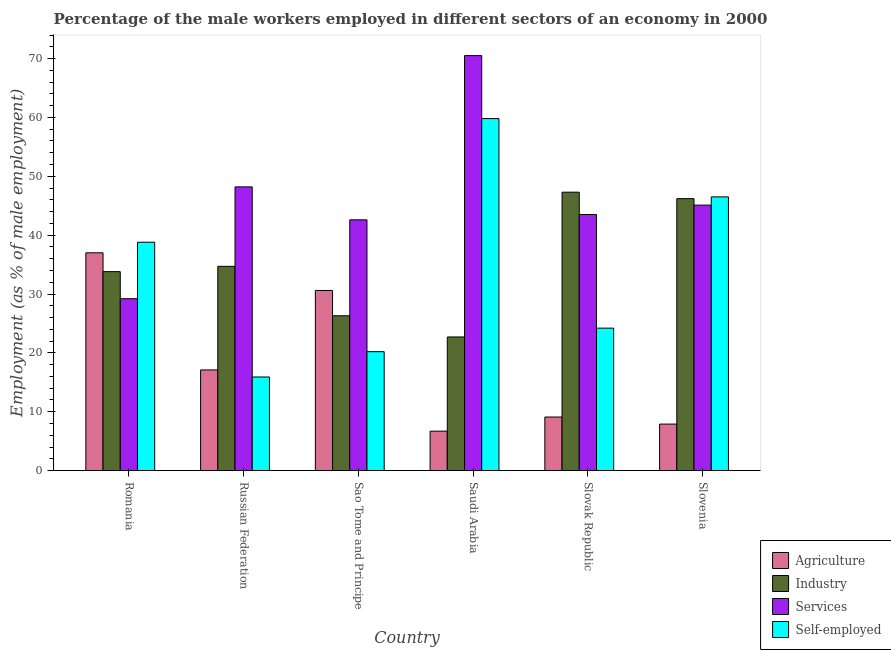How many bars are there on the 4th tick from the left?
Ensure brevity in your answer.  4. How many bars are there on the 5th tick from the right?
Your answer should be very brief. 4. What is the label of the 1st group of bars from the left?
Make the answer very short. Romania. In how many cases, is the number of bars for a given country not equal to the number of legend labels?
Offer a very short reply. 0. What is the percentage of self employed male workers in Saudi Arabia?
Give a very brief answer. 59.8. Across all countries, what is the maximum percentage of self employed male workers?
Make the answer very short. 59.8. Across all countries, what is the minimum percentage of male workers in agriculture?
Keep it short and to the point. 6.7. In which country was the percentage of male workers in services maximum?
Ensure brevity in your answer.  Saudi Arabia. In which country was the percentage of male workers in industry minimum?
Your response must be concise. Saudi Arabia. What is the total percentage of male workers in agriculture in the graph?
Keep it short and to the point. 108.4. What is the difference between the percentage of male workers in agriculture in Romania and that in Slovenia?
Offer a very short reply. 29.1. What is the difference between the percentage of male workers in industry in Romania and the percentage of male workers in agriculture in Russian Federation?
Ensure brevity in your answer.  16.7. What is the average percentage of male workers in services per country?
Make the answer very short. 46.52. What is the difference between the percentage of male workers in services and percentage of male workers in industry in Saudi Arabia?
Ensure brevity in your answer.  47.8. What is the ratio of the percentage of male workers in industry in Sao Tome and Principe to that in Slovenia?
Keep it short and to the point. 0.57. What is the difference between the highest and the second highest percentage of male workers in industry?
Keep it short and to the point. 1.1. What is the difference between the highest and the lowest percentage of male workers in agriculture?
Offer a very short reply. 30.3. What does the 1st bar from the left in Romania represents?
Give a very brief answer. Agriculture. What does the 3rd bar from the right in Slovak Republic represents?
Offer a very short reply. Industry. Is it the case that in every country, the sum of the percentage of male workers in agriculture and percentage of male workers in industry is greater than the percentage of male workers in services?
Offer a terse response. No. Are all the bars in the graph horizontal?
Provide a short and direct response. No. Where does the legend appear in the graph?
Your answer should be compact. Bottom right. What is the title of the graph?
Your answer should be compact. Percentage of the male workers employed in different sectors of an economy in 2000. What is the label or title of the Y-axis?
Offer a very short reply. Employment (as % of male employment). What is the Employment (as % of male employment) in Industry in Romania?
Your response must be concise. 33.8. What is the Employment (as % of male employment) of Services in Romania?
Offer a very short reply. 29.2. What is the Employment (as % of male employment) in Self-employed in Romania?
Provide a succinct answer. 38.8. What is the Employment (as % of male employment) in Agriculture in Russian Federation?
Your response must be concise. 17.1. What is the Employment (as % of male employment) of Industry in Russian Federation?
Provide a succinct answer. 34.7. What is the Employment (as % of male employment) in Services in Russian Federation?
Provide a succinct answer. 48.2. What is the Employment (as % of male employment) of Self-employed in Russian Federation?
Your answer should be very brief. 15.9. What is the Employment (as % of male employment) of Agriculture in Sao Tome and Principe?
Give a very brief answer. 30.6. What is the Employment (as % of male employment) in Industry in Sao Tome and Principe?
Offer a terse response. 26.3. What is the Employment (as % of male employment) in Services in Sao Tome and Principe?
Give a very brief answer. 42.6. What is the Employment (as % of male employment) of Self-employed in Sao Tome and Principe?
Give a very brief answer. 20.2. What is the Employment (as % of male employment) in Agriculture in Saudi Arabia?
Give a very brief answer. 6.7. What is the Employment (as % of male employment) in Industry in Saudi Arabia?
Your answer should be very brief. 22.7. What is the Employment (as % of male employment) of Services in Saudi Arabia?
Offer a very short reply. 70.5. What is the Employment (as % of male employment) in Self-employed in Saudi Arabia?
Provide a short and direct response. 59.8. What is the Employment (as % of male employment) in Agriculture in Slovak Republic?
Provide a succinct answer. 9.1. What is the Employment (as % of male employment) of Industry in Slovak Republic?
Keep it short and to the point. 47.3. What is the Employment (as % of male employment) in Services in Slovak Republic?
Make the answer very short. 43.5. What is the Employment (as % of male employment) of Self-employed in Slovak Republic?
Ensure brevity in your answer.  24.2. What is the Employment (as % of male employment) of Agriculture in Slovenia?
Offer a terse response. 7.9. What is the Employment (as % of male employment) in Industry in Slovenia?
Your answer should be compact. 46.2. What is the Employment (as % of male employment) of Services in Slovenia?
Your answer should be compact. 45.1. What is the Employment (as % of male employment) in Self-employed in Slovenia?
Your response must be concise. 46.5. Across all countries, what is the maximum Employment (as % of male employment) in Agriculture?
Keep it short and to the point. 37. Across all countries, what is the maximum Employment (as % of male employment) of Industry?
Provide a succinct answer. 47.3. Across all countries, what is the maximum Employment (as % of male employment) of Services?
Your response must be concise. 70.5. Across all countries, what is the maximum Employment (as % of male employment) of Self-employed?
Give a very brief answer. 59.8. Across all countries, what is the minimum Employment (as % of male employment) in Agriculture?
Offer a terse response. 6.7. Across all countries, what is the minimum Employment (as % of male employment) in Industry?
Offer a terse response. 22.7. Across all countries, what is the minimum Employment (as % of male employment) in Services?
Provide a short and direct response. 29.2. Across all countries, what is the minimum Employment (as % of male employment) of Self-employed?
Your response must be concise. 15.9. What is the total Employment (as % of male employment) of Agriculture in the graph?
Provide a succinct answer. 108.4. What is the total Employment (as % of male employment) of Industry in the graph?
Ensure brevity in your answer.  211. What is the total Employment (as % of male employment) of Services in the graph?
Make the answer very short. 279.1. What is the total Employment (as % of male employment) of Self-employed in the graph?
Your answer should be compact. 205.4. What is the difference between the Employment (as % of male employment) of Agriculture in Romania and that in Russian Federation?
Offer a very short reply. 19.9. What is the difference between the Employment (as % of male employment) in Industry in Romania and that in Russian Federation?
Your answer should be very brief. -0.9. What is the difference between the Employment (as % of male employment) of Self-employed in Romania and that in Russian Federation?
Your response must be concise. 22.9. What is the difference between the Employment (as % of male employment) of Industry in Romania and that in Sao Tome and Principe?
Offer a very short reply. 7.5. What is the difference between the Employment (as % of male employment) of Self-employed in Romania and that in Sao Tome and Principe?
Your answer should be very brief. 18.6. What is the difference between the Employment (as % of male employment) in Agriculture in Romania and that in Saudi Arabia?
Offer a terse response. 30.3. What is the difference between the Employment (as % of male employment) of Industry in Romania and that in Saudi Arabia?
Your answer should be compact. 11.1. What is the difference between the Employment (as % of male employment) in Services in Romania and that in Saudi Arabia?
Provide a succinct answer. -41.3. What is the difference between the Employment (as % of male employment) in Self-employed in Romania and that in Saudi Arabia?
Keep it short and to the point. -21. What is the difference between the Employment (as % of male employment) of Agriculture in Romania and that in Slovak Republic?
Give a very brief answer. 27.9. What is the difference between the Employment (as % of male employment) in Services in Romania and that in Slovak Republic?
Give a very brief answer. -14.3. What is the difference between the Employment (as % of male employment) of Agriculture in Romania and that in Slovenia?
Provide a short and direct response. 29.1. What is the difference between the Employment (as % of male employment) of Industry in Romania and that in Slovenia?
Offer a terse response. -12.4. What is the difference between the Employment (as % of male employment) in Services in Romania and that in Slovenia?
Offer a terse response. -15.9. What is the difference between the Employment (as % of male employment) in Self-employed in Romania and that in Slovenia?
Offer a very short reply. -7.7. What is the difference between the Employment (as % of male employment) of Industry in Russian Federation and that in Sao Tome and Principe?
Your response must be concise. 8.4. What is the difference between the Employment (as % of male employment) of Services in Russian Federation and that in Sao Tome and Principe?
Your answer should be very brief. 5.6. What is the difference between the Employment (as % of male employment) in Self-employed in Russian Federation and that in Sao Tome and Principe?
Make the answer very short. -4.3. What is the difference between the Employment (as % of male employment) in Services in Russian Federation and that in Saudi Arabia?
Provide a succinct answer. -22.3. What is the difference between the Employment (as % of male employment) in Self-employed in Russian Federation and that in Saudi Arabia?
Your response must be concise. -43.9. What is the difference between the Employment (as % of male employment) of Agriculture in Russian Federation and that in Slovak Republic?
Your response must be concise. 8. What is the difference between the Employment (as % of male employment) of Services in Russian Federation and that in Slovak Republic?
Make the answer very short. 4.7. What is the difference between the Employment (as % of male employment) of Self-employed in Russian Federation and that in Slovak Republic?
Offer a terse response. -8.3. What is the difference between the Employment (as % of male employment) in Services in Russian Federation and that in Slovenia?
Provide a short and direct response. 3.1. What is the difference between the Employment (as % of male employment) of Self-employed in Russian Federation and that in Slovenia?
Ensure brevity in your answer.  -30.6. What is the difference between the Employment (as % of male employment) of Agriculture in Sao Tome and Principe and that in Saudi Arabia?
Make the answer very short. 23.9. What is the difference between the Employment (as % of male employment) of Services in Sao Tome and Principe and that in Saudi Arabia?
Provide a succinct answer. -27.9. What is the difference between the Employment (as % of male employment) of Self-employed in Sao Tome and Principe and that in Saudi Arabia?
Make the answer very short. -39.6. What is the difference between the Employment (as % of male employment) of Industry in Sao Tome and Principe and that in Slovak Republic?
Your answer should be compact. -21. What is the difference between the Employment (as % of male employment) in Agriculture in Sao Tome and Principe and that in Slovenia?
Provide a short and direct response. 22.7. What is the difference between the Employment (as % of male employment) in Industry in Sao Tome and Principe and that in Slovenia?
Ensure brevity in your answer.  -19.9. What is the difference between the Employment (as % of male employment) in Self-employed in Sao Tome and Principe and that in Slovenia?
Offer a very short reply. -26.3. What is the difference between the Employment (as % of male employment) in Agriculture in Saudi Arabia and that in Slovak Republic?
Ensure brevity in your answer.  -2.4. What is the difference between the Employment (as % of male employment) of Industry in Saudi Arabia and that in Slovak Republic?
Give a very brief answer. -24.6. What is the difference between the Employment (as % of male employment) in Self-employed in Saudi Arabia and that in Slovak Republic?
Provide a succinct answer. 35.6. What is the difference between the Employment (as % of male employment) of Agriculture in Saudi Arabia and that in Slovenia?
Offer a very short reply. -1.2. What is the difference between the Employment (as % of male employment) of Industry in Saudi Arabia and that in Slovenia?
Make the answer very short. -23.5. What is the difference between the Employment (as % of male employment) in Services in Saudi Arabia and that in Slovenia?
Offer a terse response. 25.4. What is the difference between the Employment (as % of male employment) in Self-employed in Saudi Arabia and that in Slovenia?
Your answer should be compact. 13.3. What is the difference between the Employment (as % of male employment) of Agriculture in Slovak Republic and that in Slovenia?
Give a very brief answer. 1.2. What is the difference between the Employment (as % of male employment) of Industry in Slovak Republic and that in Slovenia?
Make the answer very short. 1.1. What is the difference between the Employment (as % of male employment) of Self-employed in Slovak Republic and that in Slovenia?
Your answer should be very brief. -22.3. What is the difference between the Employment (as % of male employment) of Agriculture in Romania and the Employment (as % of male employment) of Self-employed in Russian Federation?
Keep it short and to the point. 21.1. What is the difference between the Employment (as % of male employment) in Industry in Romania and the Employment (as % of male employment) in Services in Russian Federation?
Offer a terse response. -14.4. What is the difference between the Employment (as % of male employment) of Industry in Romania and the Employment (as % of male employment) of Self-employed in Russian Federation?
Provide a short and direct response. 17.9. What is the difference between the Employment (as % of male employment) of Agriculture in Romania and the Employment (as % of male employment) of Industry in Sao Tome and Principe?
Provide a short and direct response. 10.7. What is the difference between the Employment (as % of male employment) of Industry in Romania and the Employment (as % of male employment) of Self-employed in Sao Tome and Principe?
Keep it short and to the point. 13.6. What is the difference between the Employment (as % of male employment) in Services in Romania and the Employment (as % of male employment) in Self-employed in Sao Tome and Principe?
Offer a terse response. 9. What is the difference between the Employment (as % of male employment) of Agriculture in Romania and the Employment (as % of male employment) of Industry in Saudi Arabia?
Ensure brevity in your answer.  14.3. What is the difference between the Employment (as % of male employment) of Agriculture in Romania and the Employment (as % of male employment) of Services in Saudi Arabia?
Give a very brief answer. -33.5. What is the difference between the Employment (as % of male employment) in Agriculture in Romania and the Employment (as % of male employment) in Self-employed in Saudi Arabia?
Your answer should be very brief. -22.8. What is the difference between the Employment (as % of male employment) in Industry in Romania and the Employment (as % of male employment) in Services in Saudi Arabia?
Make the answer very short. -36.7. What is the difference between the Employment (as % of male employment) of Services in Romania and the Employment (as % of male employment) of Self-employed in Saudi Arabia?
Make the answer very short. -30.6. What is the difference between the Employment (as % of male employment) of Agriculture in Romania and the Employment (as % of male employment) of Industry in Slovak Republic?
Keep it short and to the point. -10.3. What is the difference between the Employment (as % of male employment) in Industry in Romania and the Employment (as % of male employment) in Services in Slovak Republic?
Your response must be concise. -9.7. What is the difference between the Employment (as % of male employment) of Industry in Romania and the Employment (as % of male employment) of Self-employed in Slovak Republic?
Keep it short and to the point. 9.6. What is the difference between the Employment (as % of male employment) in Agriculture in Romania and the Employment (as % of male employment) in Industry in Slovenia?
Keep it short and to the point. -9.2. What is the difference between the Employment (as % of male employment) in Industry in Romania and the Employment (as % of male employment) in Services in Slovenia?
Your response must be concise. -11.3. What is the difference between the Employment (as % of male employment) of Services in Romania and the Employment (as % of male employment) of Self-employed in Slovenia?
Give a very brief answer. -17.3. What is the difference between the Employment (as % of male employment) of Agriculture in Russian Federation and the Employment (as % of male employment) of Industry in Sao Tome and Principe?
Make the answer very short. -9.2. What is the difference between the Employment (as % of male employment) of Agriculture in Russian Federation and the Employment (as % of male employment) of Services in Sao Tome and Principe?
Offer a very short reply. -25.5. What is the difference between the Employment (as % of male employment) of Agriculture in Russian Federation and the Employment (as % of male employment) of Self-employed in Sao Tome and Principe?
Make the answer very short. -3.1. What is the difference between the Employment (as % of male employment) in Industry in Russian Federation and the Employment (as % of male employment) in Services in Sao Tome and Principe?
Make the answer very short. -7.9. What is the difference between the Employment (as % of male employment) of Industry in Russian Federation and the Employment (as % of male employment) of Self-employed in Sao Tome and Principe?
Give a very brief answer. 14.5. What is the difference between the Employment (as % of male employment) in Agriculture in Russian Federation and the Employment (as % of male employment) in Services in Saudi Arabia?
Your answer should be very brief. -53.4. What is the difference between the Employment (as % of male employment) in Agriculture in Russian Federation and the Employment (as % of male employment) in Self-employed in Saudi Arabia?
Make the answer very short. -42.7. What is the difference between the Employment (as % of male employment) of Industry in Russian Federation and the Employment (as % of male employment) of Services in Saudi Arabia?
Your answer should be compact. -35.8. What is the difference between the Employment (as % of male employment) of Industry in Russian Federation and the Employment (as % of male employment) of Self-employed in Saudi Arabia?
Provide a succinct answer. -25.1. What is the difference between the Employment (as % of male employment) in Services in Russian Federation and the Employment (as % of male employment) in Self-employed in Saudi Arabia?
Provide a succinct answer. -11.6. What is the difference between the Employment (as % of male employment) in Agriculture in Russian Federation and the Employment (as % of male employment) in Industry in Slovak Republic?
Ensure brevity in your answer.  -30.2. What is the difference between the Employment (as % of male employment) of Agriculture in Russian Federation and the Employment (as % of male employment) of Services in Slovak Republic?
Offer a terse response. -26.4. What is the difference between the Employment (as % of male employment) of Agriculture in Russian Federation and the Employment (as % of male employment) of Self-employed in Slovak Republic?
Offer a very short reply. -7.1. What is the difference between the Employment (as % of male employment) in Industry in Russian Federation and the Employment (as % of male employment) in Self-employed in Slovak Republic?
Provide a succinct answer. 10.5. What is the difference between the Employment (as % of male employment) in Services in Russian Federation and the Employment (as % of male employment) in Self-employed in Slovak Republic?
Your answer should be compact. 24. What is the difference between the Employment (as % of male employment) of Agriculture in Russian Federation and the Employment (as % of male employment) of Industry in Slovenia?
Provide a succinct answer. -29.1. What is the difference between the Employment (as % of male employment) in Agriculture in Russian Federation and the Employment (as % of male employment) in Services in Slovenia?
Provide a short and direct response. -28. What is the difference between the Employment (as % of male employment) in Agriculture in Russian Federation and the Employment (as % of male employment) in Self-employed in Slovenia?
Your response must be concise. -29.4. What is the difference between the Employment (as % of male employment) in Industry in Russian Federation and the Employment (as % of male employment) in Services in Slovenia?
Your response must be concise. -10.4. What is the difference between the Employment (as % of male employment) in Industry in Russian Federation and the Employment (as % of male employment) in Self-employed in Slovenia?
Your answer should be very brief. -11.8. What is the difference between the Employment (as % of male employment) in Services in Russian Federation and the Employment (as % of male employment) in Self-employed in Slovenia?
Provide a short and direct response. 1.7. What is the difference between the Employment (as % of male employment) in Agriculture in Sao Tome and Principe and the Employment (as % of male employment) in Services in Saudi Arabia?
Offer a terse response. -39.9. What is the difference between the Employment (as % of male employment) of Agriculture in Sao Tome and Principe and the Employment (as % of male employment) of Self-employed in Saudi Arabia?
Your answer should be very brief. -29.2. What is the difference between the Employment (as % of male employment) of Industry in Sao Tome and Principe and the Employment (as % of male employment) of Services in Saudi Arabia?
Your response must be concise. -44.2. What is the difference between the Employment (as % of male employment) in Industry in Sao Tome and Principe and the Employment (as % of male employment) in Self-employed in Saudi Arabia?
Your response must be concise. -33.5. What is the difference between the Employment (as % of male employment) in Services in Sao Tome and Principe and the Employment (as % of male employment) in Self-employed in Saudi Arabia?
Give a very brief answer. -17.2. What is the difference between the Employment (as % of male employment) in Agriculture in Sao Tome and Principe and the Employment (as % of male employment) in Industry in Slovak Republic?
Provide a succinct answer. -16.7. What is the difference between the Employment (as % of male employment) of Agriculture in Sao Tome and Principe and the Employment (as % of male employment) of Services in Slovak Republic?
Your answer should be compact. -12.9. What is the difference between the Employment (as % of male employment) of Agriculture in Sao Tome and Principe and the Employment (as % of male employment) of Self-employed in Slovak Republic?
Keep it short and to the point. 6.4. What is the difference between the Employment (as % of male employment) of Industry in Sao Tome and Principe and the Employment (as % of male employment) of Services in Slovak Republic?
Your answer should be compact. -17.2. What is the difference between the Employment (as % of male employment) in Services in Sao Tome and Principe and the Employment (as % of male employment) in Self-employed in Slovak Republic?
Offer a very short reply. 18.4. What is the difference between the Employment (as % of male employment) in Agriculture in Sao Tome and Principe and the Employment (as % of male employment) in Industry in Slovenia?
Your answer should be compact. -15.6. What is the difference between the Employment (as % of male employment) in Agriculture in Sao Tome and Principe and the Employment (as % of male employment) in Services in Slovenia?
Give a very brief answer. -14.5. What is the difference between the Employment (as % of male employment) of Agriculture in Sao Tome and Principe and the Employment (as % of male employment) of Self-employed in Slovenia?
Keep it short and to the point. -15.9. What is the difference between the Employment (as % of male employment) in Industry in Sao Tome and Principe and the Employment (as % of male employment) in Services in Slovenia?
Provide a succinct answer. -18.8. What is the difference between the Employment (as % of male employment) in Industry in Sao Tome and Principe and the Employment (as % of male employment) in Self-employed in Slovenia?
Ensure brevity in your answer.  -20.2. What is the difference between the Employment (as % of male employment) of Agriculture in Saudi Arabia and the Employment (as % of male employment) of Industry in Slovak Republic?
Provide a short and direct response. -40.6. What is the difference between the Employment (as % of male employment) of Agriculture in Saudi Arabia and the Employment (as % of male employment) of Services in Slovak Republic?
Give a very brief answer. -36.8. What is the difference between the Employment (as % of male employment) of Agriculture in Saudi Arabia and the Employment (as % of male employment) of Self-employed in Slovak Republic?
Give a very brief answer. -17.5. What is the difference between the Employment (as % of male employment) of Industry in Saudi Arabia and the Employment (as % of male employment) of Services in Slovak Republic?
Give a very brief answer. -20.8. What is the difference between the Employment (as % of male employment) of Services in Saudi Arabia and the Employment (as % of male employment) of Self-employed in Slovak Republic?
Offer a very short reply. 46.3. What is the difference between the Employment (as % of male employment) of Agriculture in Saudi Arabia and the Employment (as % of male employment) of Industry in Slovenia?
Provide a succinct answer. -39.5. What is the difference between the Employment (as % of male employment) of Agriculture in Saudi Arabia and the Employment (as % of male employment) of Services in Slovenia?
Your answer should be compact. -38.4. What is the difference between the Employment (as % of male employment) of Agriculture in Saudi Arabia and the Employment (as % of male employment) of Self-employed in Slovenia?
Your answer should be very brief. -39.8. What is the difference between the Employment (as % of male employment) in Industry in Saudi Arabia and the Employment (as % of male employment) in Services in Slovenia?
Your answer should be very brief. -22.4. What is the difference between the Employment (as % of male employment) of Industry in Saudi Arabia and the Employment (as % of male employment) of Self-employed in Slovenia?
Offer a terse response. -23.8. What is the difference between the Employment (as % of male employment) of Services in Saudi Arabia and the Employment (as % of male employment) of Self-employed in Slovenia?
Your answer should be compact. 24. What is the difference between the Employment (as % of male employment) of Agriculture in Slovak Republic and the Employment (as % of male employment) of Industry in Slovenia?
Make the answer very short. -37.1. What is the difference between the Employment (as % of male employment) of Agriculture in Slovak Republic and the Employment (as % of male employment) of Services in Slovenia?
Provide a short and direct response. -36. What is the difference between the Employment (as % of male employment) of Agriculture in Slovak Republic and the Employment (as % of male employment) of Self-employed in Slovenia?
Offer a terse response. -37.4. What is the difference between the Employment (as % of male employment) in Services in Slovak Republic and the Employment (as % of male employment) in Self-employed in Slovenia?
Provide a short and direct response. -3. What is the average Employment (as % of male employment) in Agriculture per country?
Provide a succinct answer. 18.07. What is the average Employment (as % of male employment) of Industry per country?
Your answer should be compact. 35.17. What is the average Employment (as % of male employment) in Services per country?
Provide a short and direct response. 46.52. What is the average Employment (as % of male employment) in Self-employed per country?
Your answer should be compact. 34.23. What is the difference between the Employment (as % of male employment) in Agriculture and Employment (as % of male employment) in Industry in Romania?
Offer a very short reply. 3.2. What is the difference between the Employment (as % of male employment) in Agriculture and Employment (as % of male employment) in Services in Romania?
Give a very brief answer. 7.8. What is the difference between the Employment (as % of male employment) of Industry and Employment (as % of male employment) of Services in Romania?
Offer a terse response. 4.6. What is the difference between the Employment (as % of male employment) in Agriculture and Employment (as % of male employment) in Industry in Russian Federation?
Ensure brevity in your answer.  -17.6. What is the difference between the Employment (as % of male employment) of Agriculture and Employment (as % of male employment) of Services in Russian Federation?
Give a very brief answer. -31.1. What is the difference between the Employment (as % of male employment) in Agriculture and Employment (as % of male employment) in Self-employed in Russian Federation?
Offer a very short reply. 1.2. What is the difference between the Employment (as % of male employment) in Industry and Employment (as % of male employment) in Services in Russian Federation?
Give a very brief answer. -13.5. What is the difference between the Employment (as % of male employment) of Services and Employment (as % of male employment) of Self-employed in Russian Federation?
Provide a succinct answer. 32.3. What is the difference between the Employment (as % of male employment) in Agriculture and Employment (as % of male employment) in Services in Sao Tome and Principe?
Make the answer very short. -12. What is the difference between the Employment (as % of male employment) of Industry and Employment (as % of male employment) of Services in Sao Tome and Principe?
Ensure brevity in your answer.  -16.3. What is the difference between the Employment (as % of male employment) of Industry and Employment (as % of male employment) of Self-employed in Sao Tome and Principe?
Provide a short and direct response. 6.1. What is the difference between the Employment (as % of male employment) of Services and Employment (as % of male employment) of Self-employed in Sao Tome and Principe?
Ensure brevity in your answer.  22.4. What is the difference between the Employment (as % of male employment) in Agriculture and Employment (as % of male employment) in Services in Saudi Arabia?
Provide a succinct answer. -63.8. What is the difference between the Employment (as % of male employment) in Agriculture and Employment (as % of male employment) in Self-employed in Saudi Arabia?
Offer a terse response. -53.1. What is the difference between the Employment (as % of male employment) in Industry and Employment (as % of male employment) in Services in Saudi Arabia?
Keep it short and to the point. -47.8. What is the difference between the Employment (as % of male employment) of Industry and Employment (as % of male employment) of Self-employed in Saudi Arabia?
Make the answer very short. -37.1. What is the difference between the Employment (as % of male employment) of Services and Employment (as % of male employment) of Self-employed in Saudi Arabia?
Make the answer very short. 10.7. What is the difference between the Employment (as % of male employment) in Agriculture and Employment (as % of male employment) in Industry in Slovak Republic?
Keep it short and to the point. -38.2. What is the difference between the Employment (as % of male employment) of Agriculture and Employment (as % of male employment) of Services in Slovak Republic?
Your answer should be compact. -34.4. What is the difference between the Employment (as % of male employment) in Agriculture and Employment (as % of male employment) in Self-employed in Slovak Republic?
Your response must be concise. -15.1. What is the difference between the Employment (as % of male employment) of Industry and Employment (as % of male employment) of Services in Slovak Republic?
Keep it short and to the point. 3.8. What is the difference between the Employment (as % of male employment) of Industry and Employment (as % of male employment) of Self-employed in Slovak Republic?
Ensure brevity in your answer.  23.1. What is the difference between the Employment (as % of male employment) of Services and Employment (as % of male employment) of Self-employed in Slovak Republic?
Your answer should be very brief. 19.3. What is the difference between the Employment (as % of male employment) of Agriculture and Employment (as % of male employment) of Industry in Slovenia?
Provide a short and direct response. -38.3. What is the difference between the Employment (as % of male employment) of Agriculture and Employment (as % of male employment) of Services in Slovenia?
Make the answer very short. -37.2. What is the difference between the Employment (as % of male employment) of Agriculture and Employment (as % of male employment) of Self-employed in Slovenia?
Your answer should be very brief. -38.6. What is the difference between the Employment (as % of male employment) of Industry and Employment (as % of male employment) of Services in Slovenia?
Offer a terse response. 1.1. What is the difference between the Employment (as % of male employment) in Industry and Employment (as % of male employment) in Self-employed in Slovenia?
Your answer should be compact. -0.3. What is the ratio of the Employment (as % of male employment) in Agriculture in Romania to that in Russian Federation?
Provide a short and direct response. 2.16. What is the ratio of the Employment (as % of male employment) of Industry in Romania to that in Russian Federation?
Provide a short and direct response. 0.97. What is the ratio of the Employment (as % of male employment) of Services in Romania to that in Russian Federation?
Your response must be concise. 0.61. What is the ratio of the Employment (as % of male employment) in Self-employed in Romania to that in Russian Federation?
Provide a short and direct response. 2.44. What is the ratio of the Employment (as % of male employment) of Agriculture in Romania to that in Sao Tome and Principe?
Offer a terse response. 1.21. What is the ratio of the Employment (as % of male employment) of Industry in Romania to that in Sao Tome and Principe?
Keep it short and to the point. 1.29. What is the ratio of the Employment (as % of male employment) in Services in Romania to that in Sao Tome and Principe?
Provide a short and direct response. 0.69. What is the ratio of the Employment (as % of male employment) in Self-employed in Romania to that in Sao Tome and Principe?
Your answer should be compact. 1.92. What is the ratio of the Employment (as % of male employment) of Agriculture in Romania to that in Saudi Arabia?
Offer a very short reply. 5.52. What is the ratio of the Employment (as % of male employment) of Industry in Romania to that in Saudi Arabia?
Ensure brevity in your answer.  1.49. What is the ratio of the Employment (as % of male employment) of Services in Romania to that in Saudi Arabia?
Offer a very short reply. 0.41. What is the ratio of the Employment (as % of male employment) in Self-employed in Romania to that in Saudi Arabia?
Keep it short and to the point. 0.65. What is the ratio of the Employment (as % of male employment) of Agriculture in Romania to that in Slovak Republic?
Provide a succinct answer. 4.07. What is the ratio of the Employment (as % of male employment) in Industry in Romania to that in Slovak Republic?
Your answer should be compact. 0.71. What is the ratio of the Employment (as % of male employment) in Services in Romania to that in Slovak Republic?
Your answer should be compact. 0.67. What is the ratio of the Employment (as % of male employment) in Self-employed in Romania to that in Slovak Republic?
Provide a succinct answer. 1.6. What is the ratio of the Employment (as % of male employment) of Agriculture in Romania to that in Slovenia?
Provide a succinct answer. 4.68. What is the ratio of the Employment (as % of male employment) of Industry in Romania to that in Slovenia?
Keep it short and to the point. 0.73. What is the ratio of the Employment (as % of male employment) in Services in Romania to that in Slovenia?
Keep it short and to the point. 0.65. What is the ratio of the Employment (as % of male employment) of Self-employed in Romania to that in Slovenia?
Your answer should be compact. 0.83. What is the ratio of the Employment (as % of male employment) in Agriculture in Russian Federation to that in Sao Tome and Principe?
Offer a very short reply. 0.56. What is the ratio of the Employment (as % of male employment) in Industry in Russian Federation to that in Sao Tome and Principe?
Your response must be concise. 1.32. What is the ratio of the Employment (as % of male employment) of Services in Russian Federation to that in Sao Tome and Principe?
Your response must be concise. 1.13. What is the ratio of the Employment (as % of male employment) in Self-employed in Russian Federation to that in Sao Tome and Principe?
Make the answer very short. 0.79. What is the ratio of the Employment (as % of male employment) in Agriculture in Russian Federation to that in Saudi Arabia?
Make the answer very short. 2.55. What is the ratio of the Employment (as % of male employment) in Industry in Russian Federation to that in Saudi Arabia?
Ensure brevity in your answer.  1.53. What is the ratio of the Employment (as % of male employment) in Services in Russian Federation to that in Saudi Arabia?
Your response must be concise. 0.68. What is the ratio of the Employment (as % of male employment) of Self-employed in Russian Federation to that in Saudi Arabia?
Your answer should be very brief. 0.27. What is the ratio of the Employment (as % of male employment) of Agriculture in Russian Federation to that in Slovak Republic?
Your answer should be very brief. 1.88. What is the ratio of the Employment (as % of male employment) in Industry in Russian Federation to that in Slovak Republic?
Your answer should be compact. 0.73. What is the ratio of the Employment (as % of male employment) in Services in Russian Federation to that in Slovak Republic?
Your answer should be compact. 1.11. What is the ratio of the Employment (as % of male employment) in Self-employed in Russian Federation to that in Slovak Republic?
Your answer should be compact. 0.66. What is the ratio of the Employment (as % of male employment) of Agriculture in Russian Federation to that in Slovenia?
Offer a terse response. 2.16. What is the ratio of the Employment (as % of male employment) in Industry in Russian Federation to that in Slovenia?
Ensure brevity in your answer.  0.75. What is the ratio of the Employment (as % of male employment) of Services in Russian Federation to that in Slovenia?
Your answer should be compact. 1.07. What is the ratio of the Employment (as % of male employment) of Self-employed in Russian Federation to that in Slovenia?
Make the answer very short. 0.34. What is the ratio of the Employment (as % of male employment) in Agriculture in Sao Tome and Principe to that in Saudi Arabia?
Provide a succinct answer. 4.57. What is the ratio of the Employment (as % of male employment) in Industry in Sao Tome and Principe to that in Saudi Arabia?
Ensure brevity in your answer.  1.16. What is the ratio of the Employment (as % of male employment) of Services in Sao Tome and Principe to that in Saudi Arabia?
Make the answer very short. 0.6. What is the ratio of the Employment (as % of male employment) of Self-employed in Sao Tome and Principe to that in Saudi Arabia?
Keep it short and to the point. 0.34. What is the ratio of the Employment (as % of male employment) of Agriculture in Sao Tome and Principe to that in Slovak Republic?
Provide a short and direct response. 3.36. What is the ratio of the Employment (as % of male employment) of Industry in Sao Tome and Principe to that in Slovak Republic?
Make the answer very short. 0.56. What is the ratio of the Employment (as % of male employment) of Services in Sao Tome and Principe to that in Slovak Republic?
Provide a succinct answer. 0.98. What is the ratio of the Employment (as % of male employment) of Self-employed in Sao Tome and Principe to that in Slovak Republic?
Ensure brevity in your answer.  0.83. What is the ratio of the Employment (as % of male employment) of Agriculture in Sao Tome and Principe to that in Slovenia?
Provide a succinct answer. 3.87. What is the ratio of the Employment (as % of male employment) of Industry in Sao Tome and Principe to that in Slovenia?
Offer a terse response. 0.57. What is the ratio of the Employment (as % of male employment) of Services in Sao Tome and Principe to that in Slovenia?
Your response must be concise. 0.94. What is the ratio of the Employment (as % of male employment) in Self-employed in Sao Tome and Principe to that in Slovenia?
Offer a very short reply. 0.43. What is the ratio of the Employment (as % of male employment) of Agriculture in Saudi Arabia to that in Slovak Republic?
Offer a very short reply. 0.74. What is the ratio of the Employment (as % of male employment) in Industry in Saudi Arabia to that in Slovak Republic?
Ensure brevity in your answer.  0.48. What is the ratio of the Employment (as % of male employment) in Services in Saudi Arabia to that in Slovak Republic?
Keep it short and to the point. 1.62. What is the ratio of the Employment (as % of male employment) in Self-employed in Saudi Arabia to that in Slovak Republic?
Your answer should be very brief. 2.47. What is the ratio of the Employment (as % of male employment) of Agriculture in Saudi Arabia to that in Slovenia?
Your answer should be compact. 0.85. What is the ratio of the Employment (as % of male employment) in Industry in Saudi Arabia to that in Slovenia?
Your response must be concise. 0.49. What is the ratio of the Employment (as % of male employment) in Services in Saudi Arabia to that in Slovenia?
Offer a terse response. 1.56. What is the ratio of the Employment (as % of male employment) in Self-employed in Saudi Arabia to that in Slovenia?
Keep it short and to the point. 1.29. What is the ratio of the Employment (as % of male employment) in Agriculture in Slovak Republic to that in Slovenia?
Provide a succinct answer. 1.15. What is the ratio of the Employment (as % of male employment) in Industry in Slovak Republic to that in Slovenia?
Keep it short and to the point. 1.02. What is the ratio of the Employment (as % of male employment) in Services in Slovak Republic to that in Slovenia?
Keep it short and to the point. 0.96. What is the ratio of the Employment (as % of male employment) of Self-employed in Slovak Republic to that in Slovenia?
Offer a very short reply. 0.52. What is the difference between the highest and the second highest Employment (as % of male employment) in Industry?
Offer a very short reply. 1.1. What is the difference between the highest and the second highest Employment (as % of male employment) in Services?
Offer a very short reply. 22.3. What is the difference between the highest and the lowest Employment (as % of male employment) in Agriculture?
Offer a very short reply. 30.3. What is the difference between the highest and the lowest Employment (as % of male employment) in Industry?
Offer a terse response. 24.6. What is the difference between the highest and the lowest Employment (as % of male employment) in Services?
Provide a succinct answer. 41.3. What is the difference between the highest and the lowest Employment (as % of male employment) in Self-employed?
Ensure brevity in your answer.  43.9. 